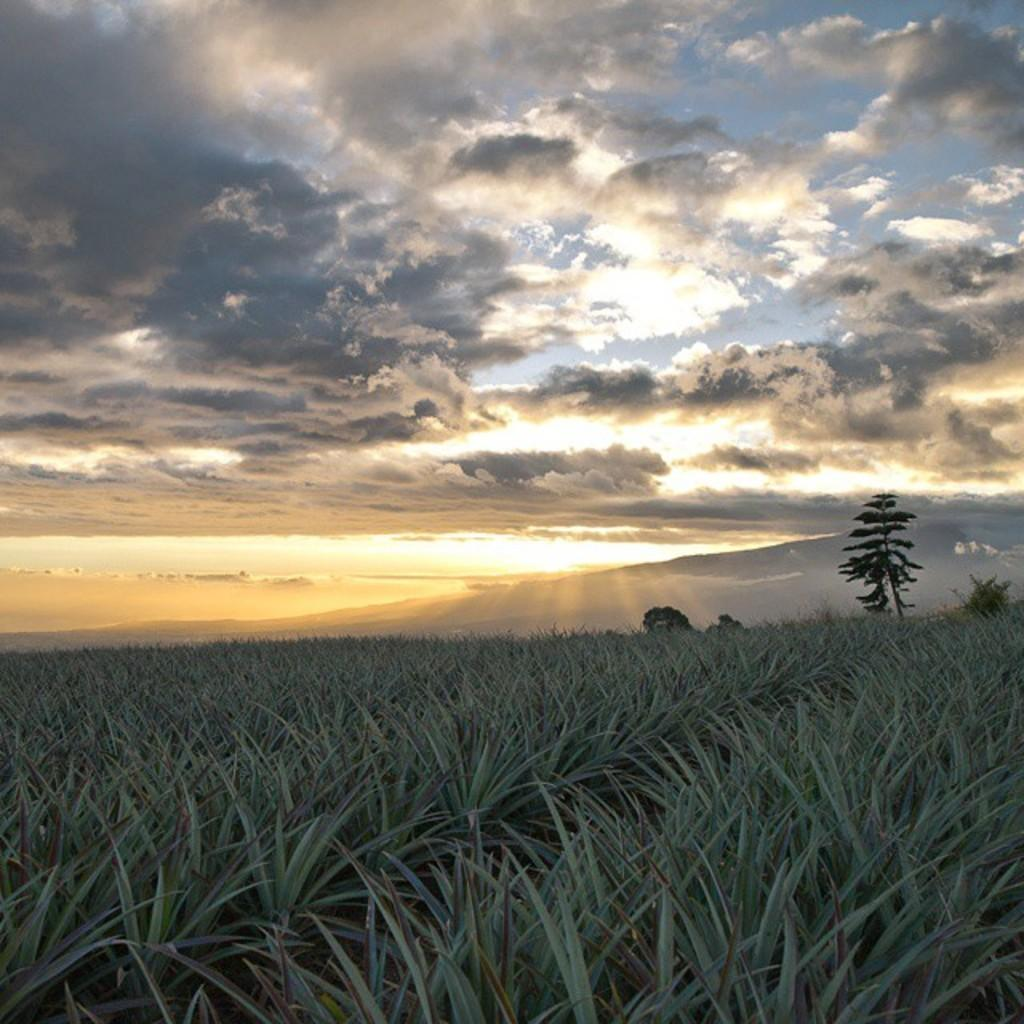What type of natural environment is visible in the image? There is grass visible in the image. What other natural elements can be seen in the image? There are trees in the image. What is the condition of the sky in the image? The sky is visible in the image and appears cloudy. Who is the creator of the park visible in the image? There is no park present in the image, so it is not possible to determine who the creator might be. 